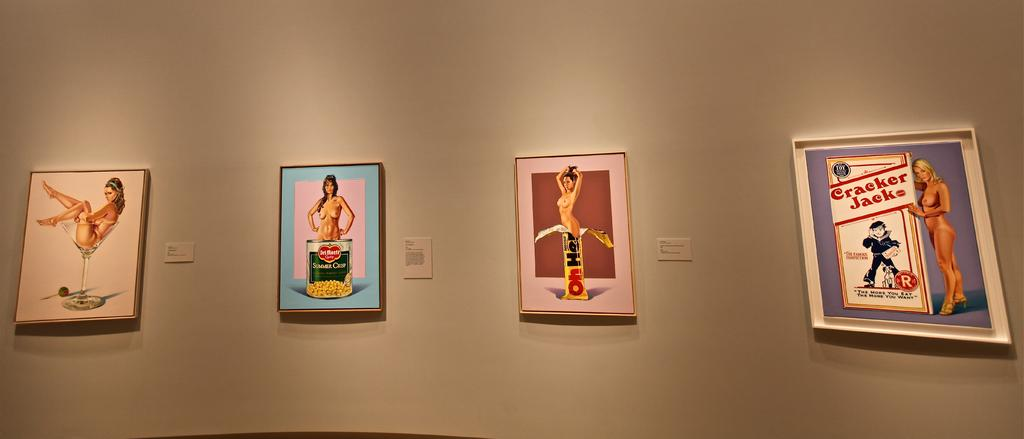<image>
Provide a brief description of the given image. A row of pictures hangs on a wall with one showing a women standing in a can of Del Monte Sweet Corn 